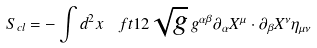<formula> <loc_0><loc_0><loc_500><loc_500>S _ { c l } = - \int d ^ { 2 } x \ \ f t { 1 } { 2 } \sqrt { g } \, g ^ { \alpha \beta } \partial _ { \alpha } X ^ { \mu } \cdot \partial _ { \beta } X ^ { \nu } \eta _ { \mu \nu }</formula> 